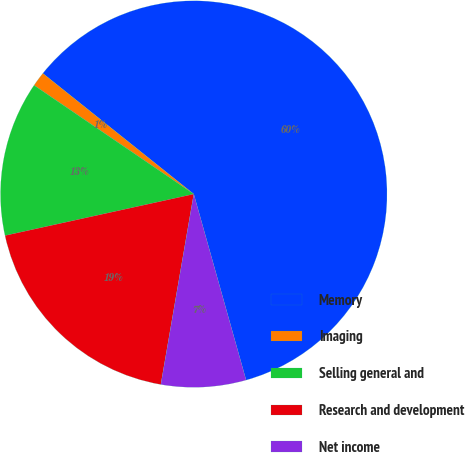Convert chart to OTSL. <chart><loc_0><loc_0><loc_500><loc_500><pie_chart><fcel>Memory<fcel>Imaging<fcel>Selling general and<fcel>Research and development<fcel>Net income<nl><fcel>59.9%<fcel>1.22%<fcel>12.96%<fcel>18.83%<fcel>7.09%<nl></chart> 